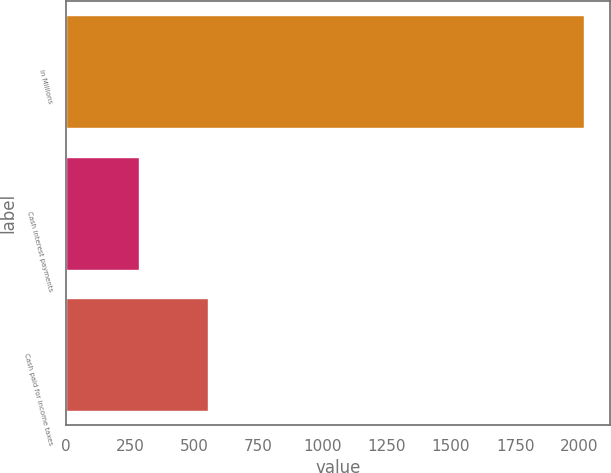<chart> <loc_0><loc_0><loc_500><loc_500><bar_chart><fcel>In Millions<fcel>Cash interest payments<fcel>Cash paid for income taxes<nl><fcel>2017<fcel>285.8<fcel>551.1<nl></chart> 